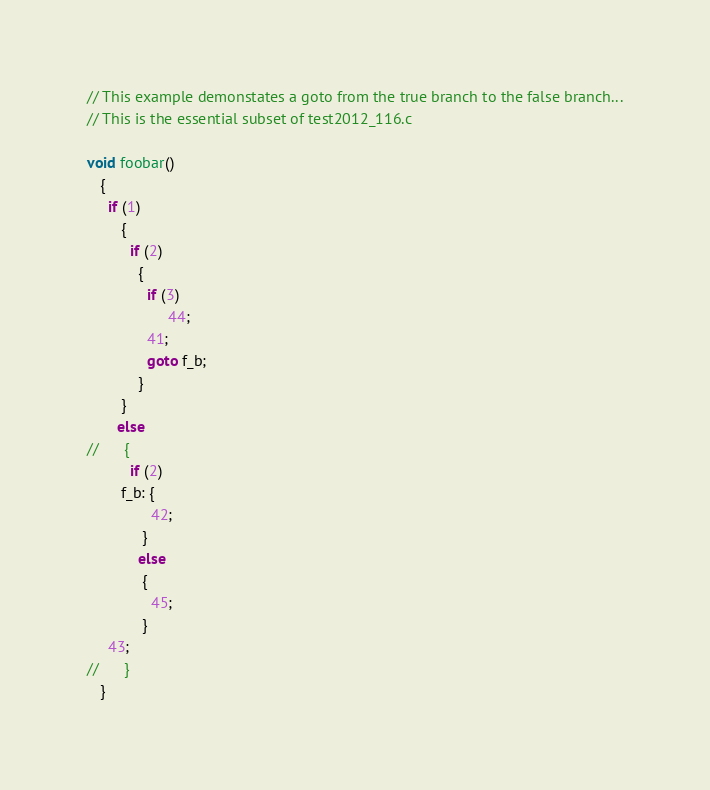<code> <loc_0><loc_0><loc_500><loc_500><_C_>// This example demonstates a goto from the true branch to the false branch...
// This is the essential subset of test2012_116.c

void foobar()
   {
     if (1)
        {
          if (2)
            {
              if (3)
                   44;
              41;
              goto f_b;
            }
        }
       else
//      {
          if (2)
        f_b: {
               42;
             }
            else
             {
               45;
             }
     43;
//      }
   }
</code> 